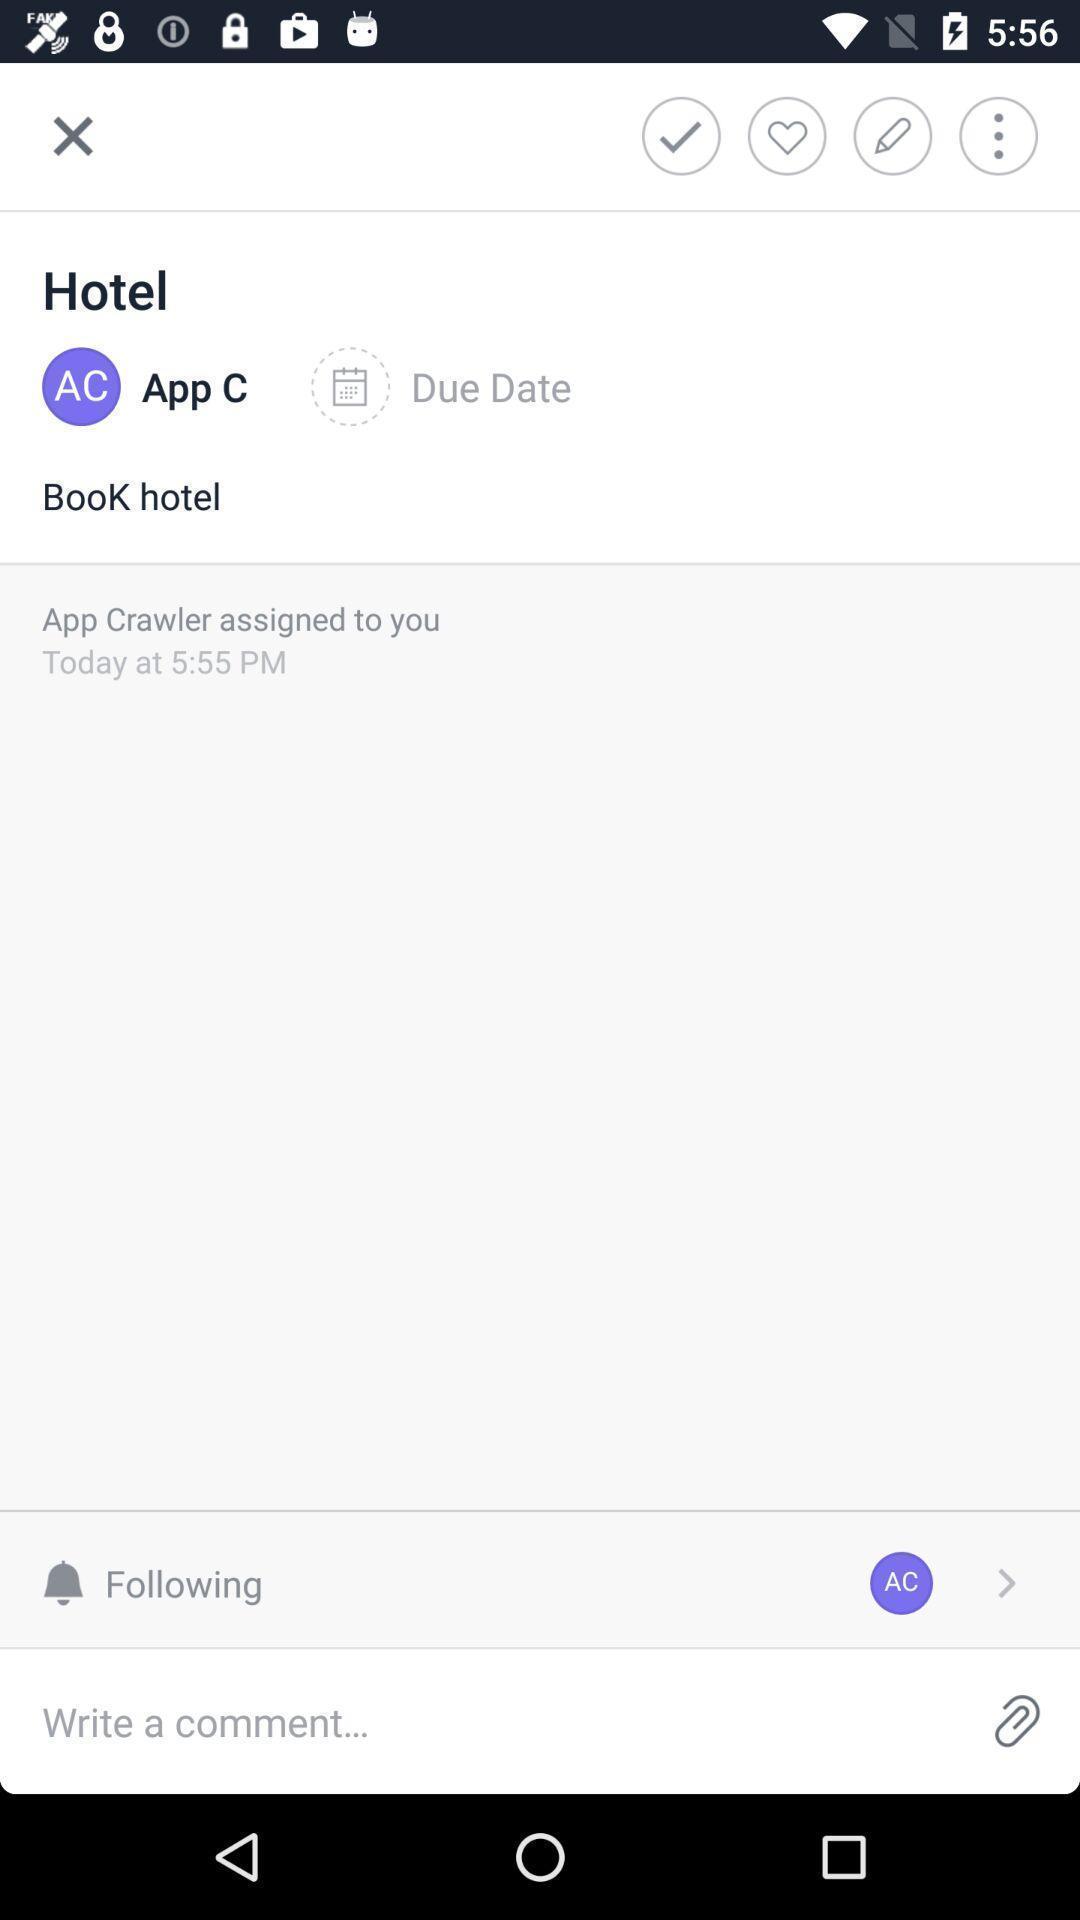Give me a summary of this screen capture. Page showing about different option in application. 